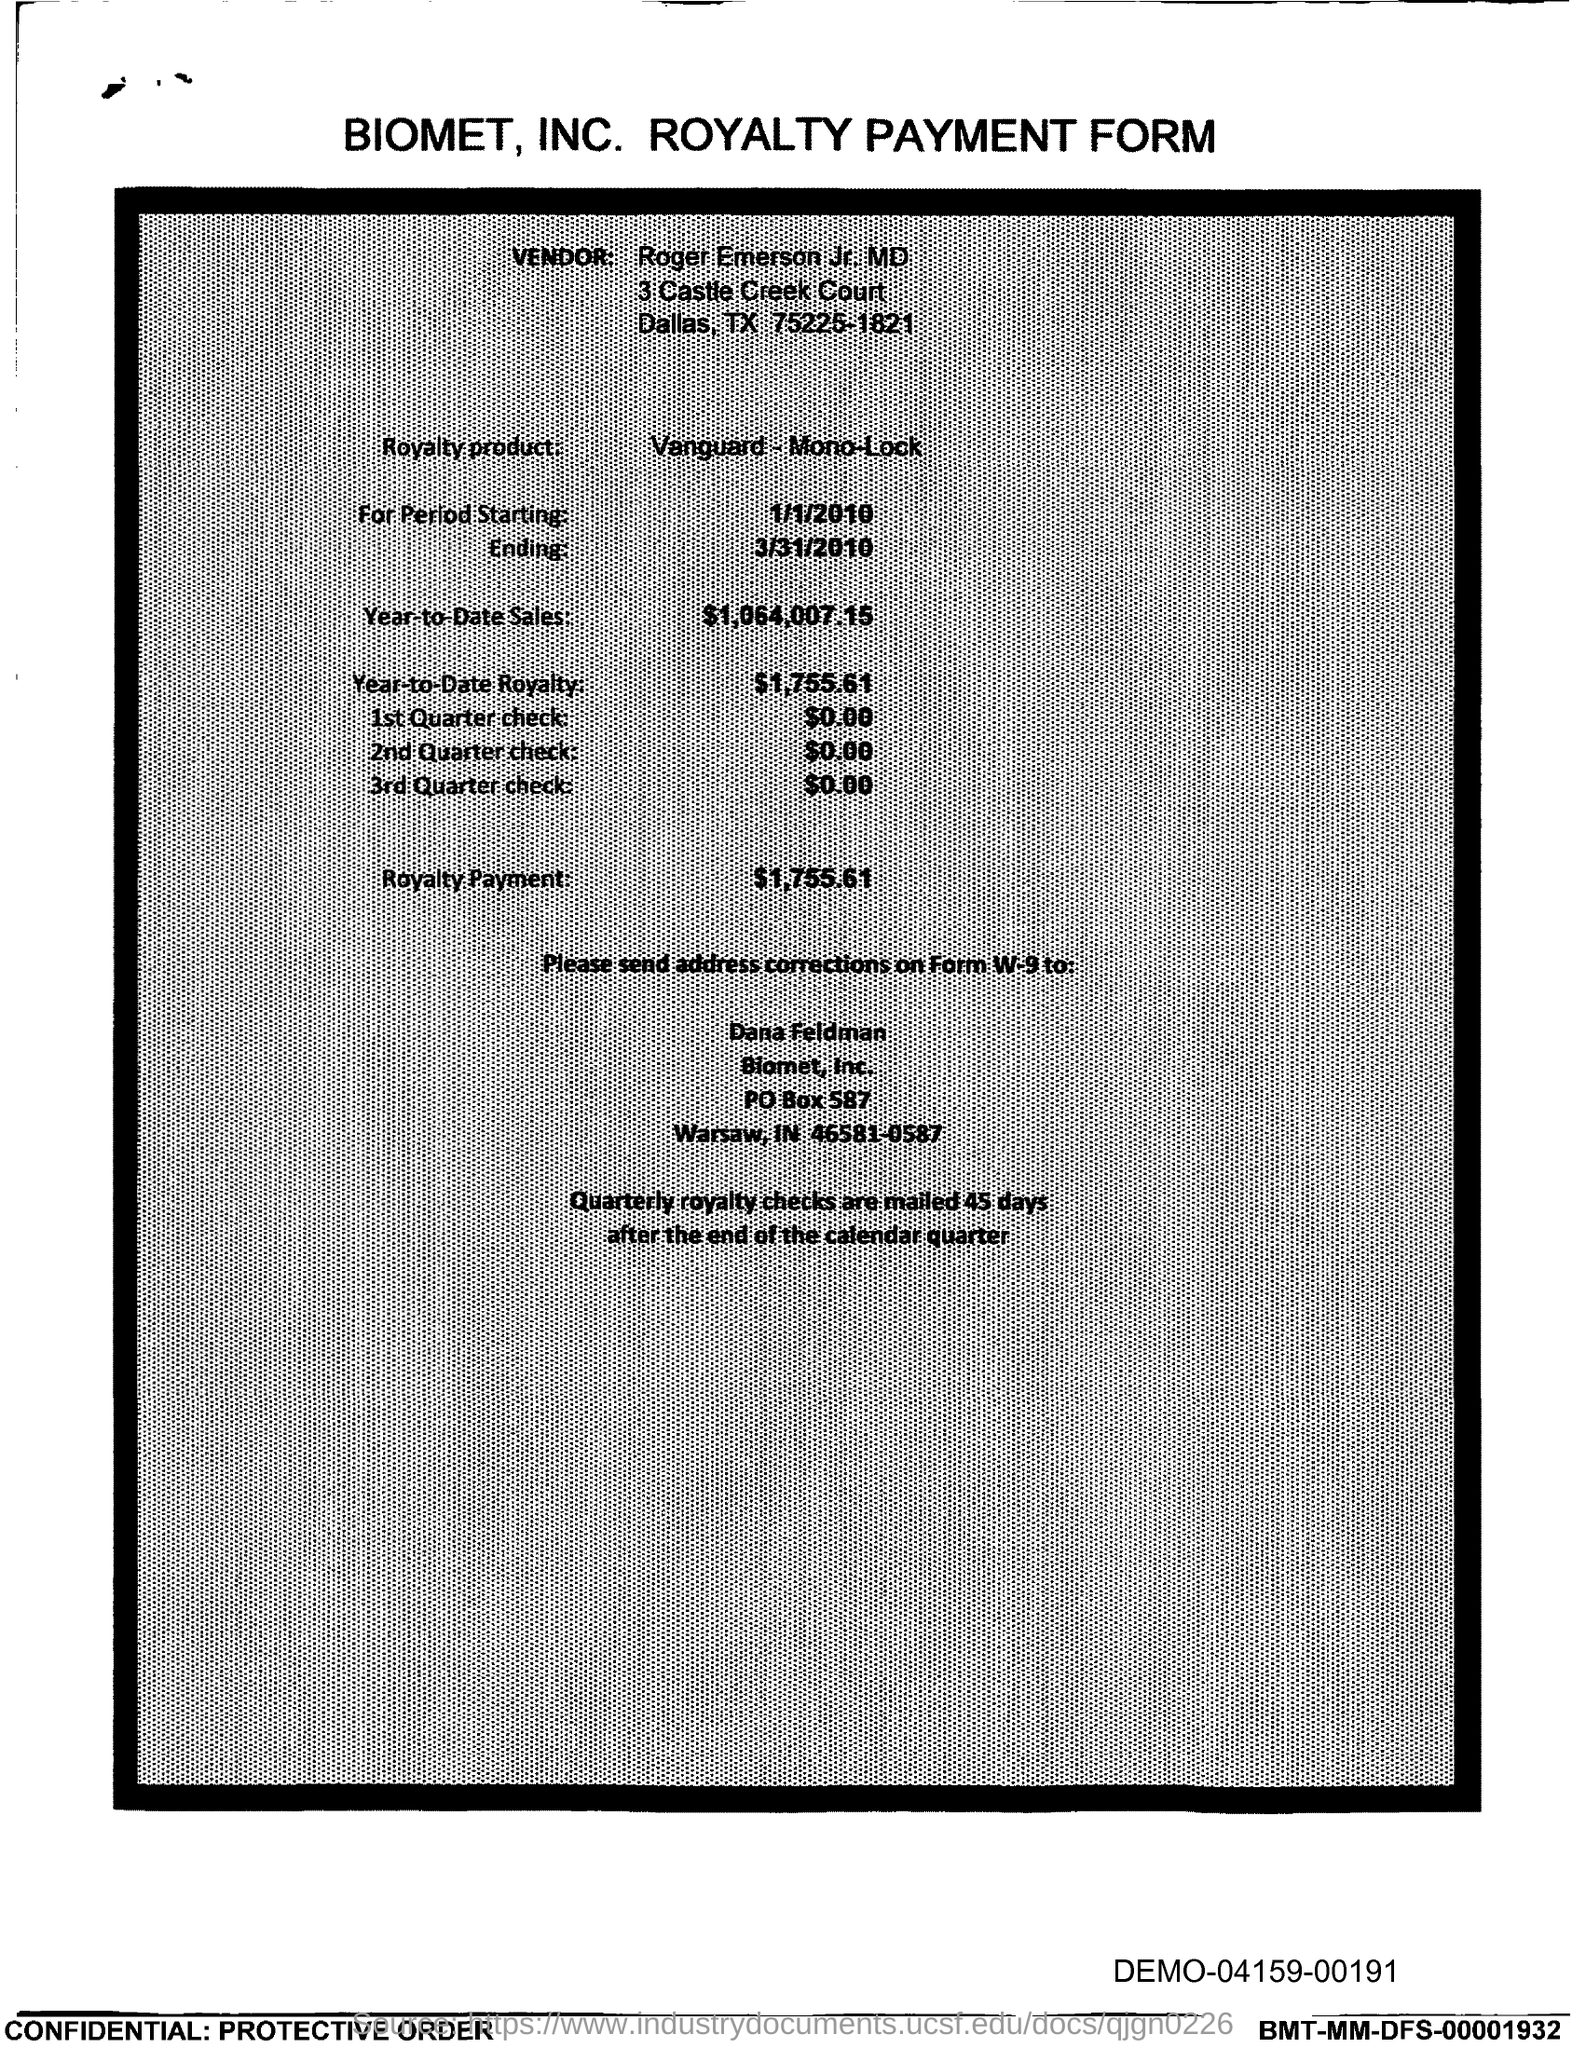In which state is biomet, inc. located ?
Provide a short and direct response. In. What is the po box no. of biomet, inc.?
Offer a very short reply. 587. What is the year-to-date sales?
Ensure brevity in your answer.  $1,064,007.15. What is the year-to-date royalty ?
Keep it short and to the point. $1,755.61. What is the royalty payment ?
Keep it short and to the point. $1,755.61. 